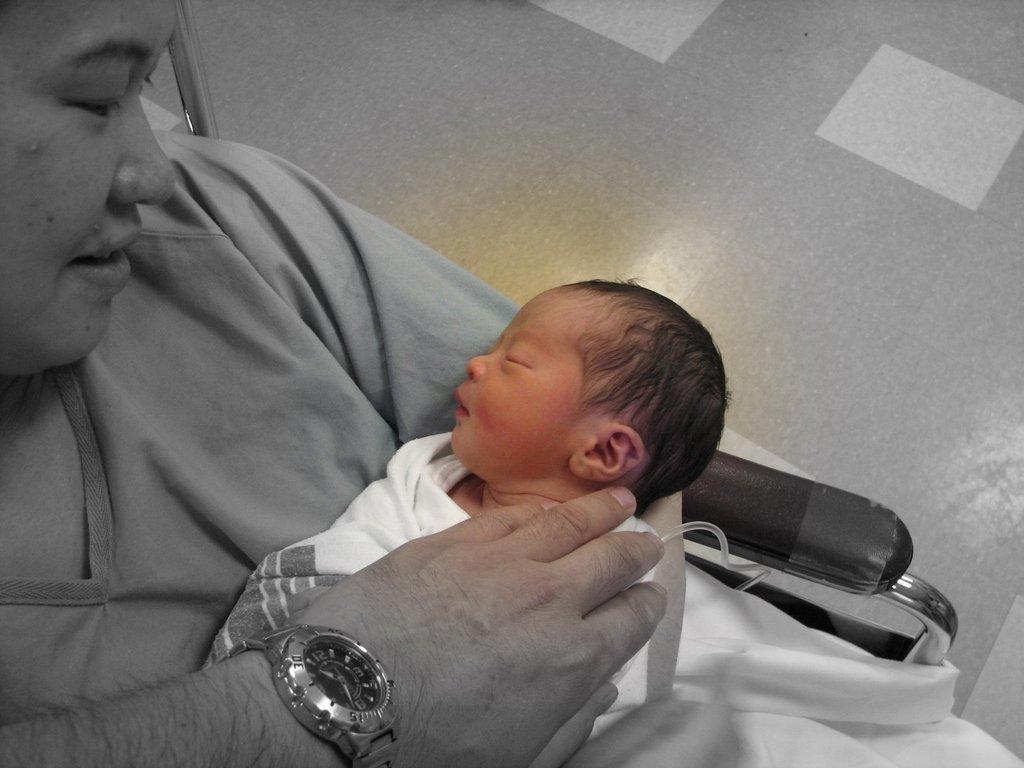Could you give a brief overview of what you see in this image? In this picture we can see a woman is sitting on a chair and holding a baby and on the baby there is a person hand with a watch. Behind the woman there is a steel rod and floor. 